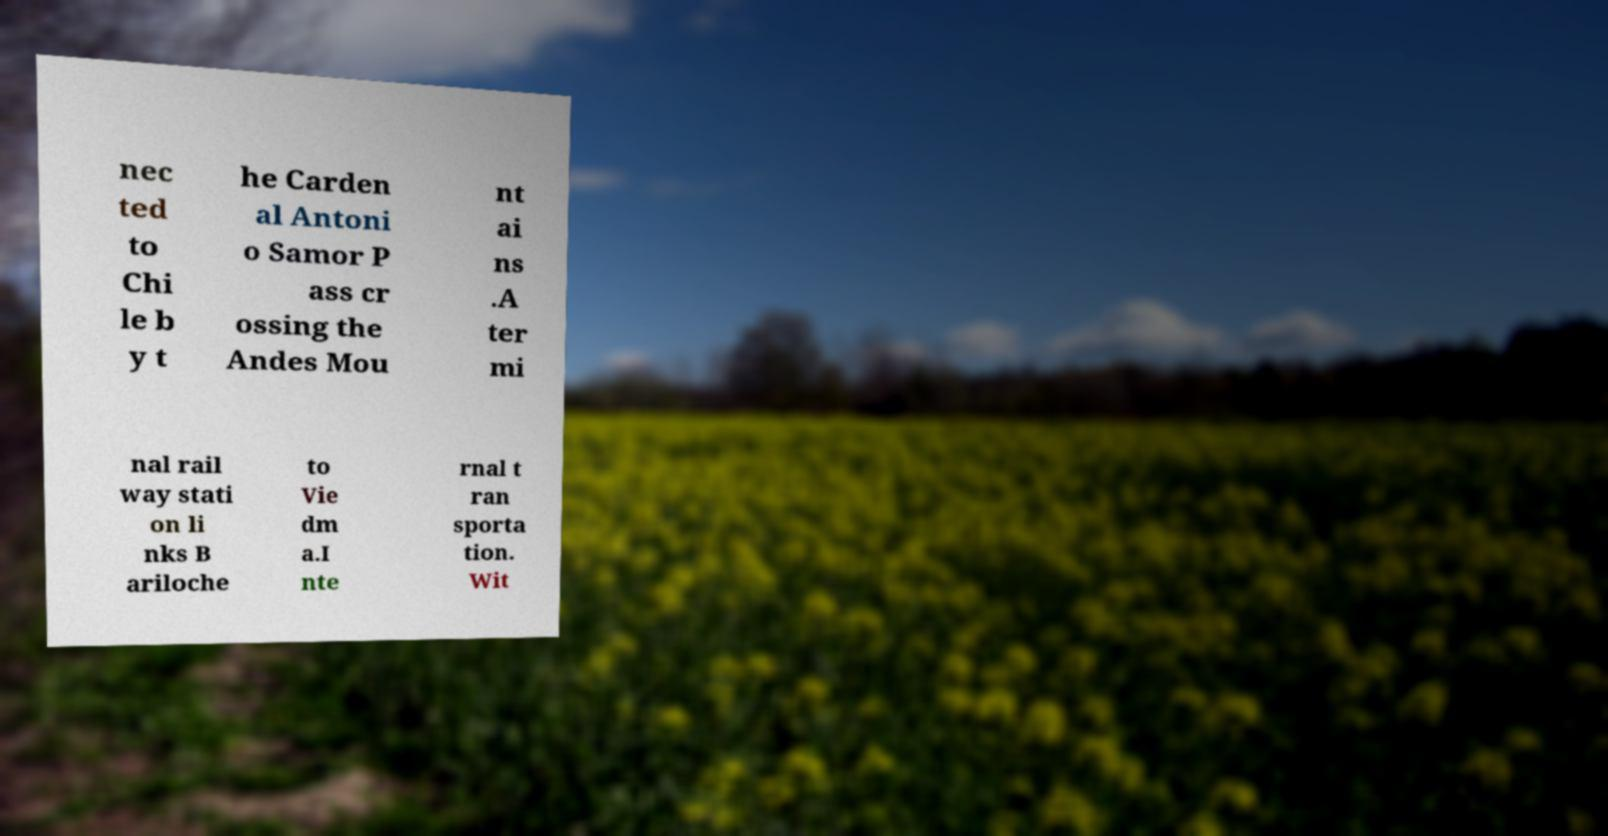Could you assist in decoding the text presented in this image and type it out clearly? nec ted to Chi le b y t he Carden al Antoni o Samor P ass cr ossing the Andes Mou nt ai ns .A ter mi nal rail way stati on li nks B ariloche to Vie dm a.I nte rnal t ran sporta tion. Wit 